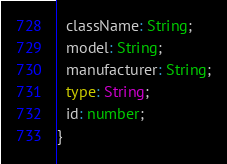<code> <loc_0><loc_0><loc_500><loc_500><_TypeScript_>  className: String;
  model: String;
  manufacturer: String;
  type: String;
  id: number;
}</code> 